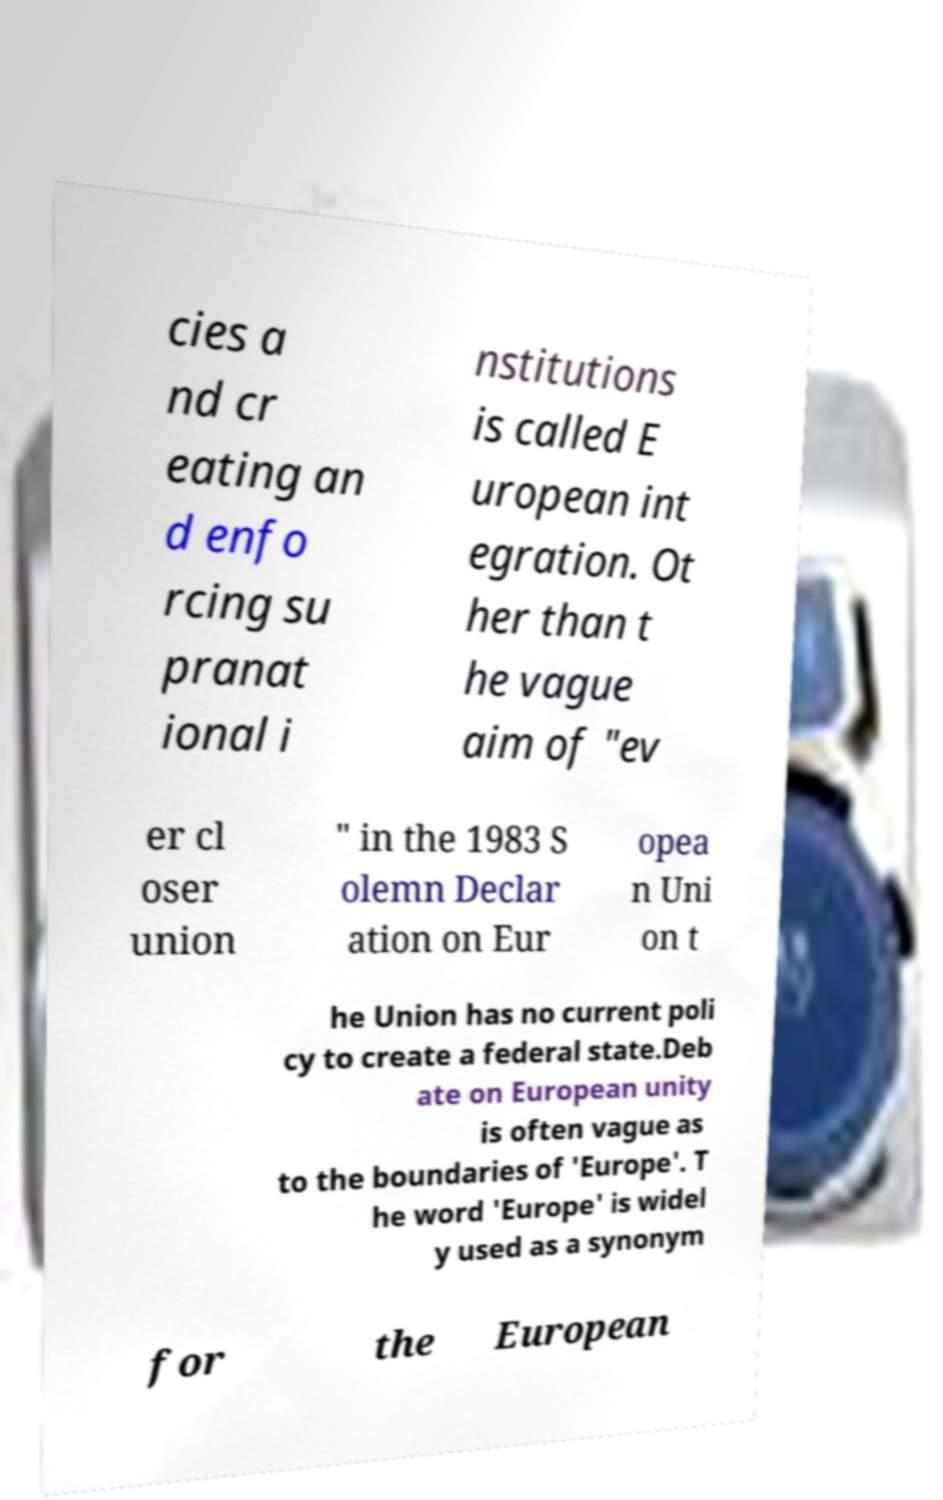Please identify and transcribe the text found in this image. cies a nd cr eating an d enfo rcing su pranat ional i nstitutions is called E uropean int egration. Ot her than t he vague aim of "ev er cl oser union " in the 1983 S olemn Declar ation on Eur opea n Uni on t he Union has no current poli cy to create a federal state.Deb ate on European unity is often vague as to the boundaries of 'Europe'. T he word 'Europe' is widel y used as a synonym for the European 